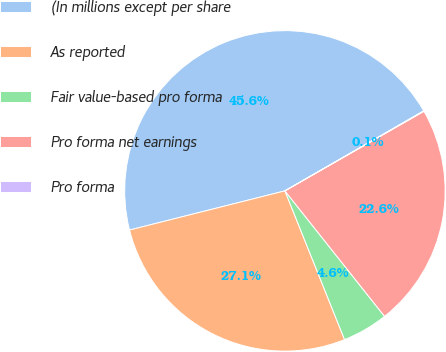Convert chart to OTSL. <chart><loc_0><loc_0><loc_500><loc_500><pie_chart><fcel>(In millions except per share<fcel>As reported<fcel>Fair value-based pro forma<fcel>Pro forma net earnings<fcel>Pro forma<nl><fcel>45.61%<fcel>27.14%<fcel>4.61%<fcel>22.59%<fcel>0.05%<nl></chart> 